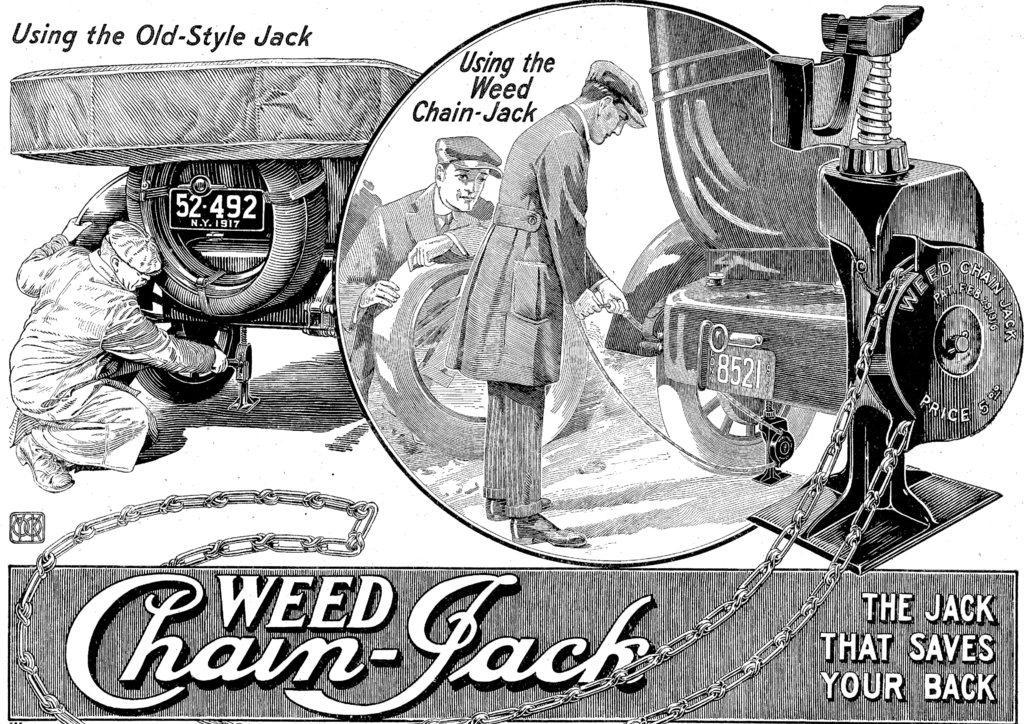Please provide a concise description of this image. This might be a poster, in this image there is text and one person and it seems that the person is repairing the vehicle. In the center there is some coin, on the coin there are two persons and vehicle and also we could see some text. On the right side there is some machine and chains. 